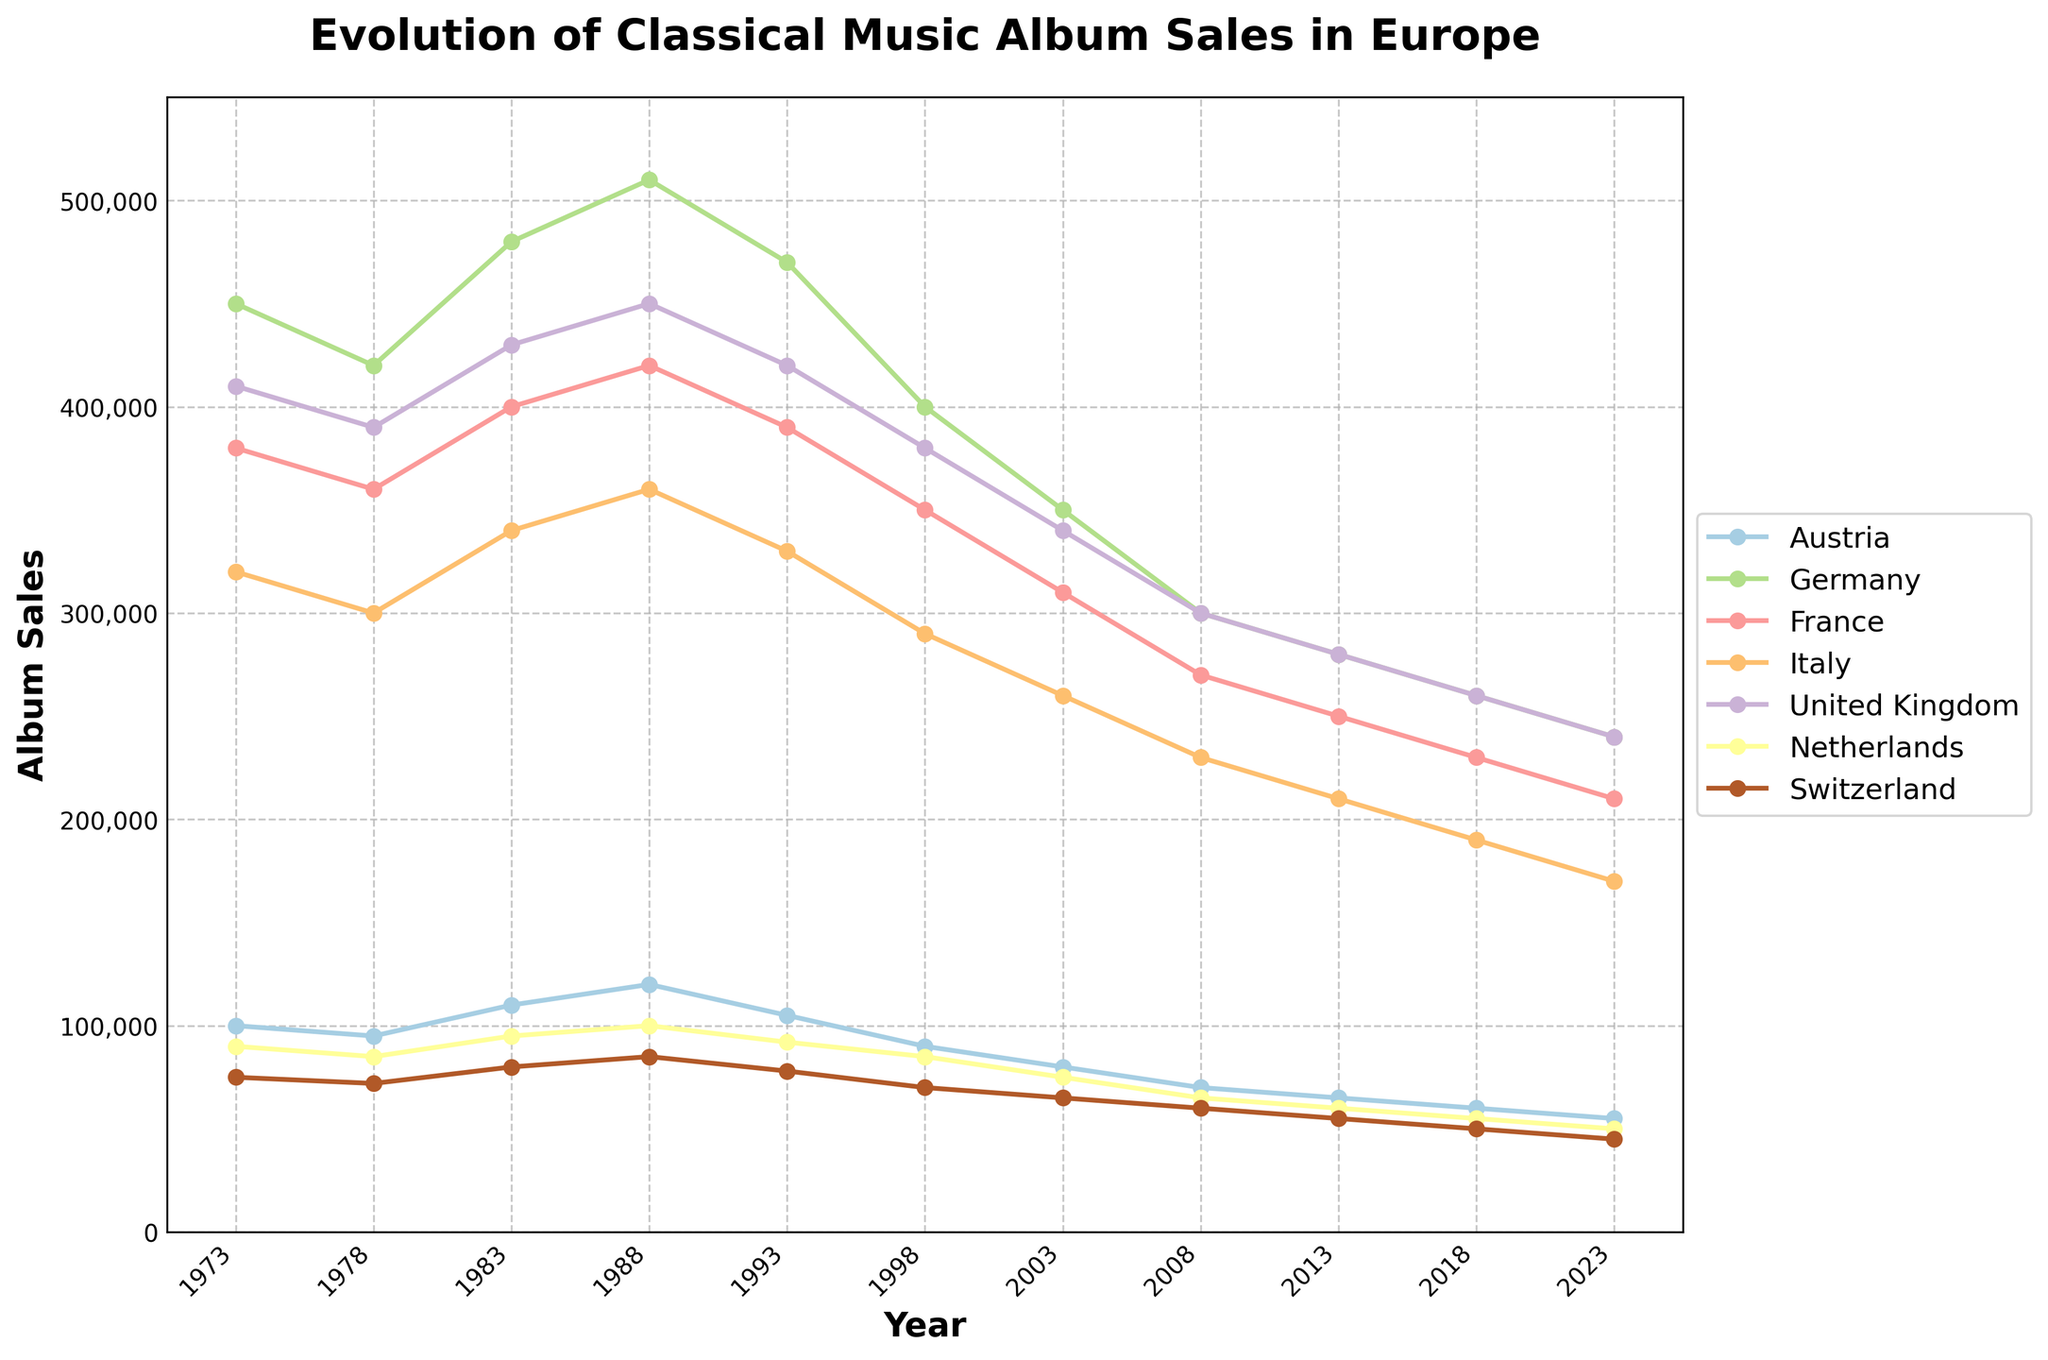Which country had the highest album sales in 1973? To find the answer, look at the plot for the year 1973 and compare the heights of the lines representing each country. The country with the highest line in that year had the highest sales.
Answer: Germany How did classical music album sales in Austria change from 1973 to 2023? Look at the endpoints of Austria's line in the years 1973 and 2023 and note the values. Calculate the difference.
Answer: Decreased by 45,000 Which country experienced the greatest decrease in album sales from 1988 to 2023? Examine the lines for each country, noting the album sales value for 1988 and 2023. Calculate the difference and find the largest decrease.
Answer: Germany What is the average album sales for the United Kingdom over the entire 50-year period? Observe the United Kingdom's album sales for each year listed, sum these values, and divide by the number of years (11).
Answer: 353,636 Between which consecutive years did France experience the steepest drop in album sales? Compare the drop between consecutive years for France by calculating the difference in album sales for each pair of consecutive years and identify the maximum drop.
Answer: 1993-1998 Comparing Italy and the Netherlands, which country has more consistent album sales over the 50-year period? Compare the volatility of the album sales trends for Italy and Netherlands. Consistency can be gauged by observing which line is flatter and less variable.
Answer: Netherlands In which year did all countries combined have their highest total album sales? Sum the album sales for all countries for each year and compare these sums to find the highest total.
Answer: 1983 What is the difference in album sales between the highest and lowest performing countries in 2023? Identify the highest and lowest album sales values for 2023 by comparing the height of the lines, then subtract the lowest from the highest value.
Answer: 195,000 How did album sales in Switzerland change from 1973 to 2008? Compare the values of Switzerland's album sales in 1973 and 2008 and compute the difference.
Answer: Decreased by 15,000 Which two countries had the closest album sales in 2018, and what were their sales? Look at the sales for each country in 2018 and find the two closest values.
Answer: United Kingdom and Italy, both 260,000 